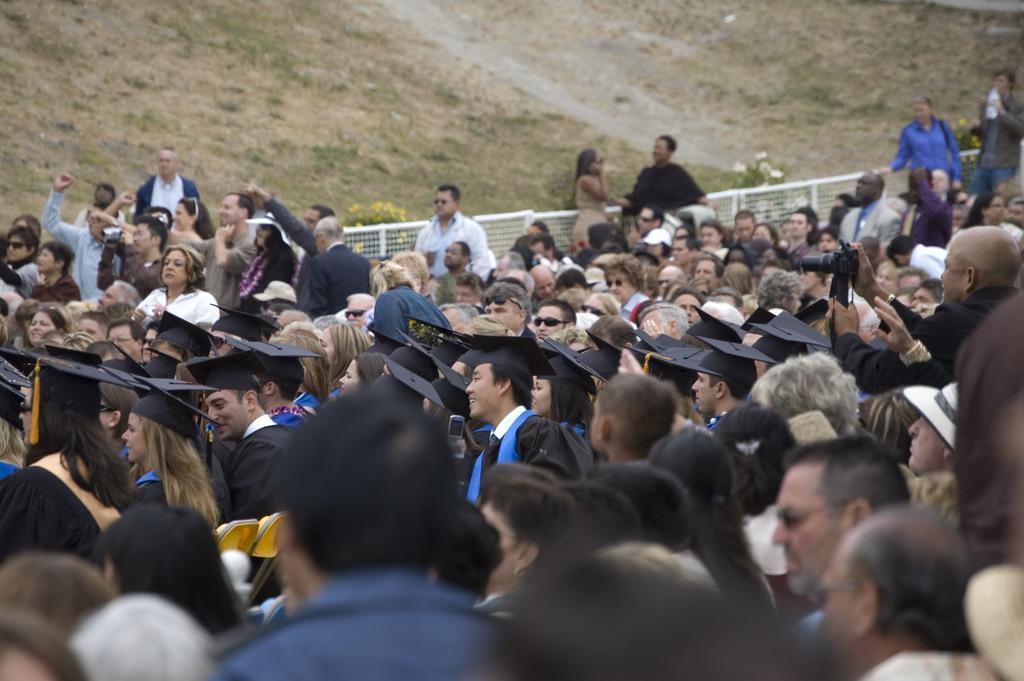How would you summarize this image in a sentence or two? In the picture we can see many people are standing and some are wearing a graduate costumes and behind the people we can see a railing and behind it, we can see a hill with grass surface and some plants and flowers to it. 